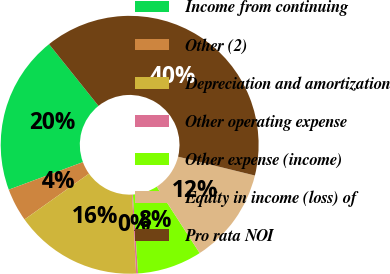<chart> <loc_0><loc_0><loc_500><loc_500><pie_chart><fcel>Income from continuing<fcel>Other (2)<fcel>Depreciation and amortization<fcel>Other operating expense<fcel>Other expense (income)<fcel>Equity in income (loss) of<fcel>Pro rata NOI<nl><fcel>19.91%<fcel>4.17%<fcel>15.97%<fcel>0.24%<fcel>8.1%<fcel>12.04%<fcel>39.58%<nl></chart> 